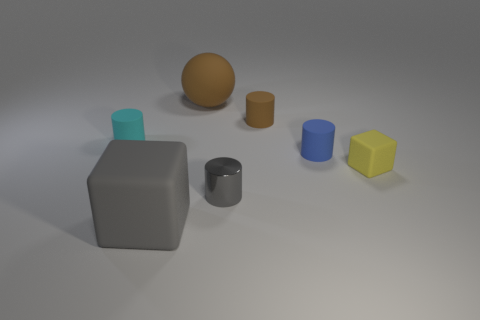Add 2 gray cubes. How many objects exist? 9 Subtract all spheres. How many objects are left? 6 Add 5 tiny gray cylinders. How many tiny gray cylinders exist? 6 Subtract 0 green cubes. How many objects are left? 7 Subtract all big rubber blocks. Subtract all balls. How many objects are left? 5 Add 7 brown matte objects. How many brown matte objects are left? 9 